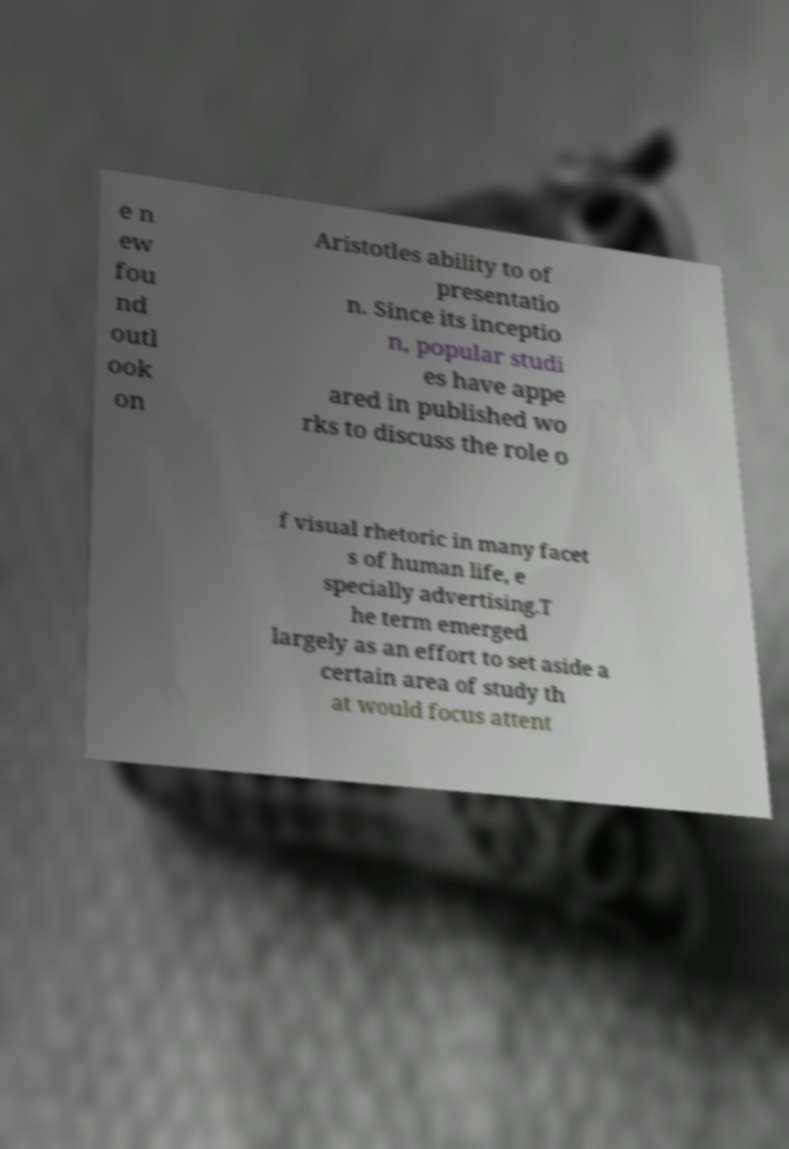For documentation purposes, I need the text within this image transcribed. Could you provide that? e n ew fou nd outl ook on Aristotles ability to of presentatio n. Since its inceptio n, popular studi es have appe ared in published wo rks to discuss the role o f visual rhetoric in many facet s of human life, e specially advertising.T he term emerged largely as an effort to set aside a certain area of study th at would focus attent 